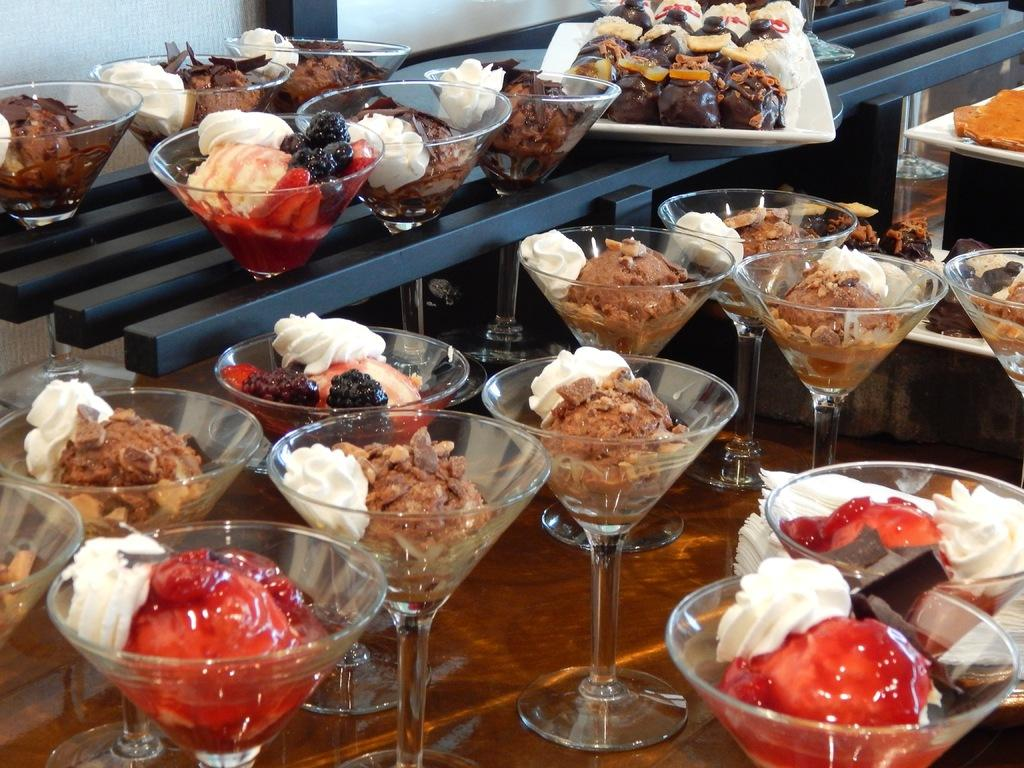What type of dessert can be seen in the image? There is ice cream in the image. What other dessert items are present in the image? There are cakes in the image. How are the ice cream and cakes served in the image? The ice cream and cakes are in glasses. What is the surface on which the glasses are placed? The glasses are on a wooden table. What can be seen in the background of the image? There are food items in a white plate in the background of the image. What type of chin is visible on the secretary in the image? There is no secretary or chin present in the image. What type of beast can be seen interacting with the ice cream in the image? There is no beast present in the image; the desserts are in glasses on a wooden table. 